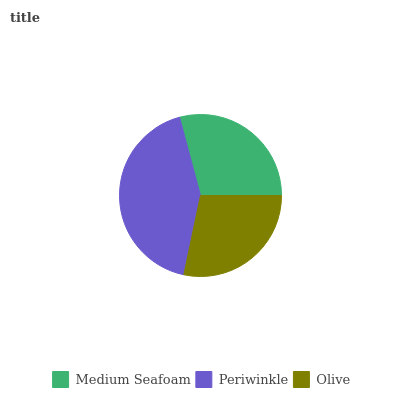Is Olive the minimum?
Answer yes or no. Yes. Is Periwinkle the maximum?
Answer yes or no. Yes. Is Periwinkle the minimum?
Answer yes or no. No. Is Olive the maximum?
Answer yes or no. No. Is Periwinkle greater than Olive?
Answer yes or no. Yes. Is Olive less than Periwinkle?
Answer yes or no. Yes. Is Olive greater than Periwinkle?
Answer yes or no. No. Is Periwinkle less than Olive?
Answer yes or no. No. Is Medium Seafoam the high median?
Answer yes or no. Yes. Is Medium Seafoam the low median?
Answer yes or no. Yes. Is Periwinkle the high median?
Answer yes or no. No. Is Periwinkle the low median?
Answer yes or no. No. 